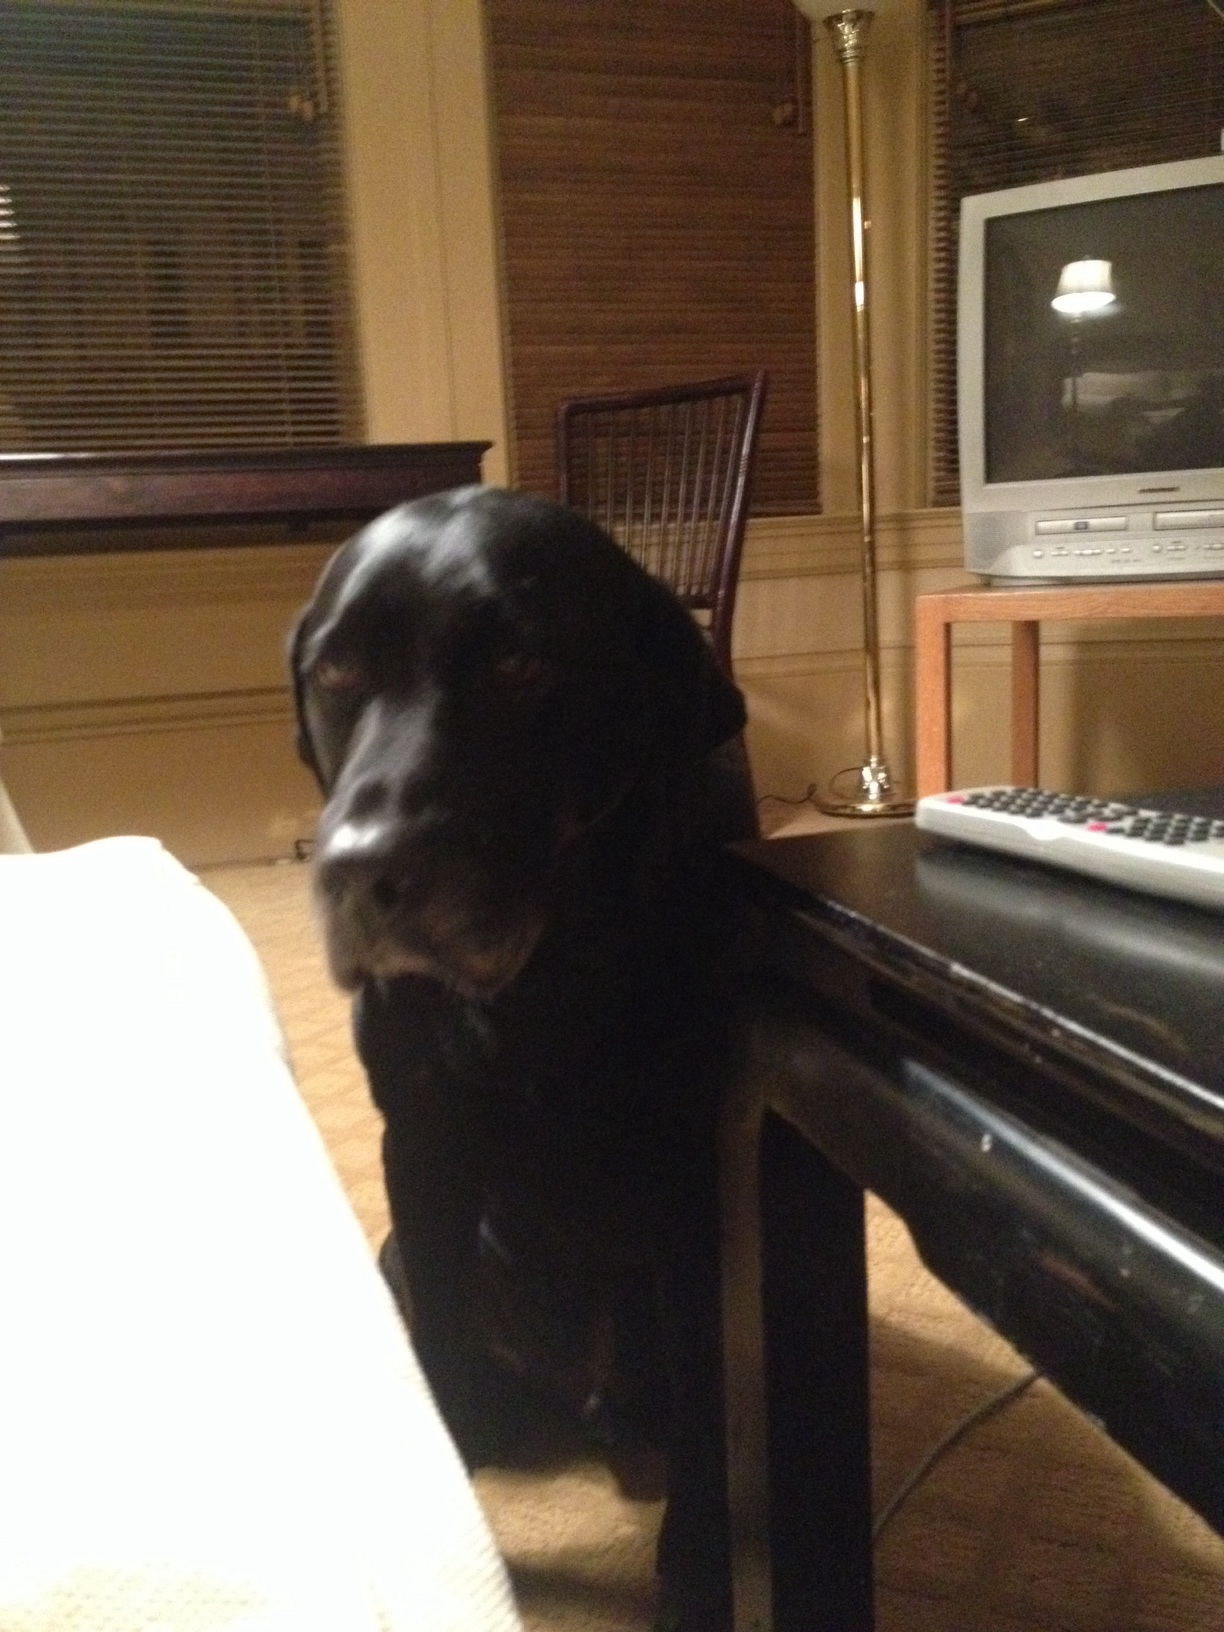What is the breed of the dog shown in the picture? The dog in the image appears to be a Labrador Retriever, a breed known for its friendly nature and shiny black coat. 